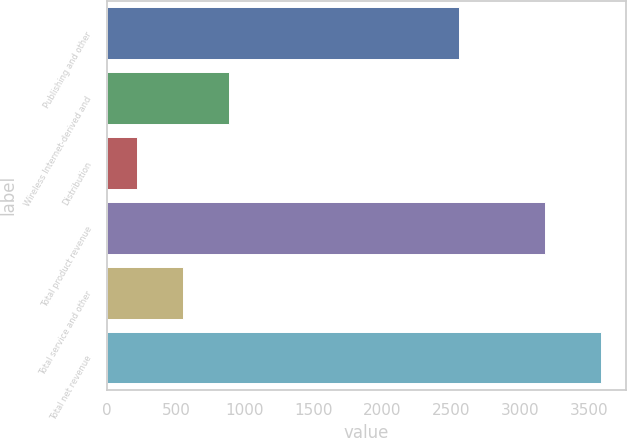<chart> <loc_0><loc_0><loc_500><loc_500><bar_chart><fcel>Publishing and other<fcel>Wireless Internet-derived and<fcel>Distribution<fcel>Total product revenue<fcel>Total service and other<fcel>Total net revenue<nl><fcel>2558<fcel>889<fcel>214<fcel>3181<fcel>551.5<fcel>3589<nl></chart> 